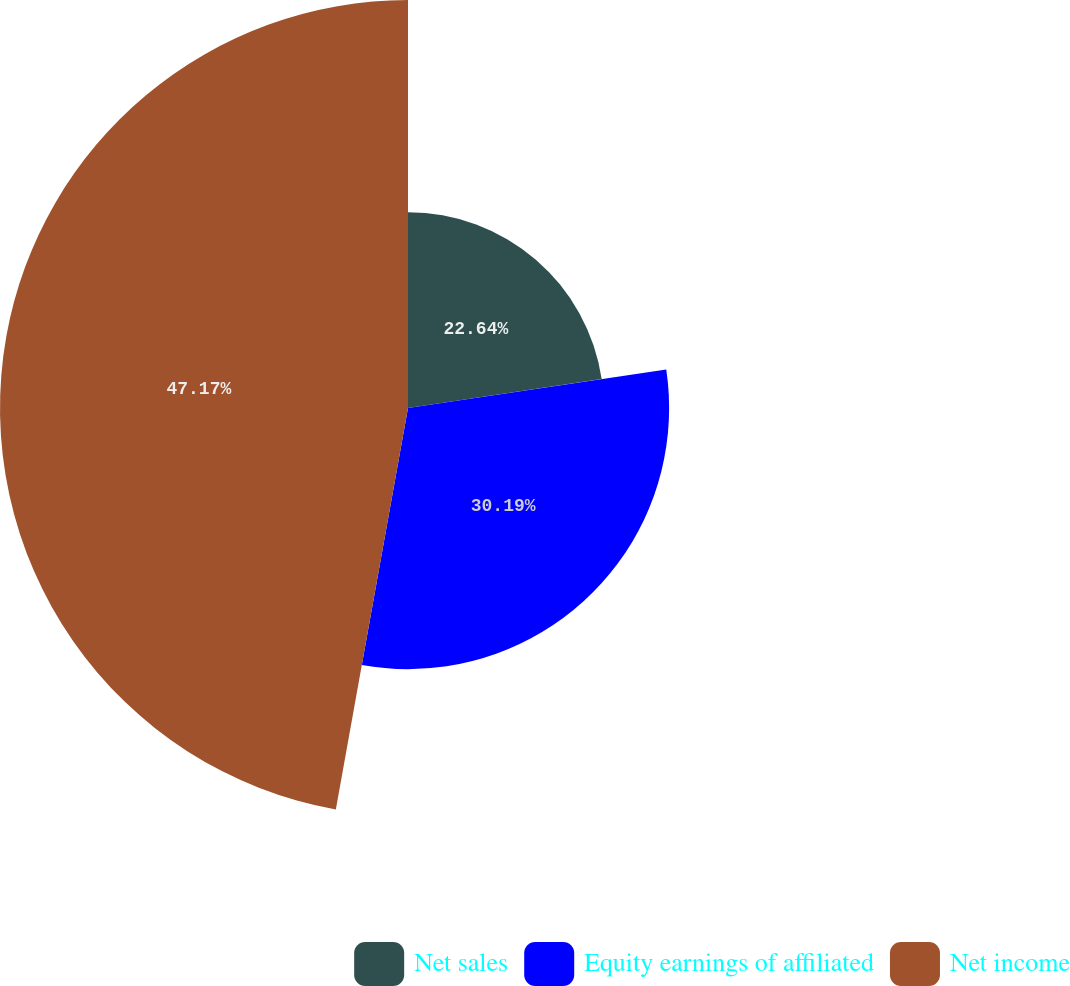<chart> <loc_0><loc_0><loc_500><loc_500><pie_chart><fcel>Net sales<fcel>Equity earnings of affiliated<fcel>Net income<nl><fcel>22.64%<fcel>30.19%<fcel>47.17%<nl></chart> 